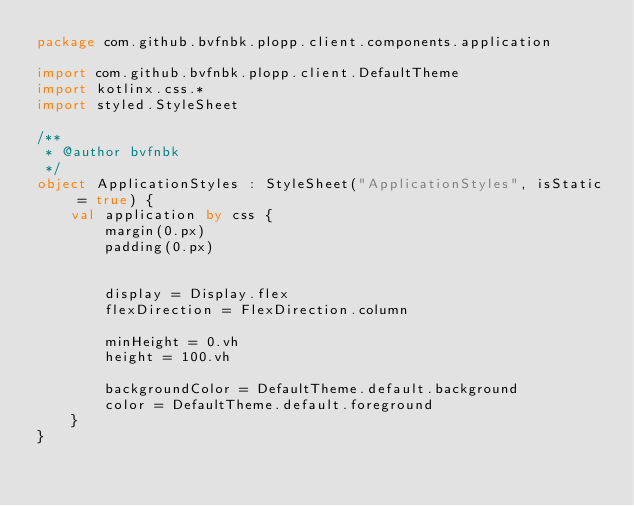<code> <loc_0><loc_0><loc_500><loc_500><_Kotlin_>package com.github.bvfnbk.plopp.client.components.application

import com.github.bvfnbk.plopp.client.DefaultTheme
import kotlinx.css.*
import styled.StyleSheet

/**
 * @author bvfnbk
 */
object ApplicationStyles : StyleSheet("ApplicationStyles", isStatic = true) {
    val application by css {
        margin(0.px)
        padding(0.px)


        display = Display.flex
        flexDirection = FlexDirection.column

        minHeight = 0.vh
        height = 100.vh

        backgroundColor = DefaultTheme.default.background
        color = DefaultTheme.default.foreground
    }
}
</code> 